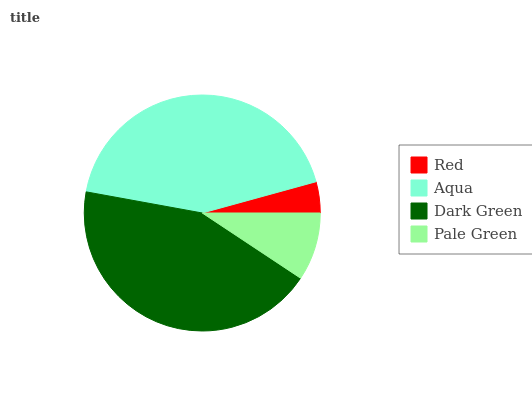Is Red the minimum?
Answer yes or no. Yes. Is Dark Green the maximum?
Answer yes or no. Yes. Is Aqua the minimum?
Answer yes or no. No. Is Aqua the maximum?
Answer yes or no. No. Is Aqua greater than Red?
Answer yes or no. Yes. Is Red less than Aqua?
Answer yes or no. Yes. Is Red greater than Aqua?
Answer yes or no. No. Is Aqua less than Red?
Answer yes or no. No. Is Aqua the high median?
Answer yes or no. Yes. Is Pale Green the low median?
Answer yes or no. Yes. Is Pale Green the high median?
Answer yes or no. No. Is Aqua the low median?
Answer yes or no. No. 